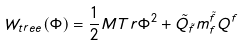<formula> <loc_0><loc_0><loc_500><loc_500>W _ { t r e e } ( \Phi ) = \frac { 1 } { 2 } M T r \Phi ^ { 2 } + \tilde { Q } _ { \tilde { f } } m _ { f } ^ { \tilde { f } } Q ^ { f }</formula> 